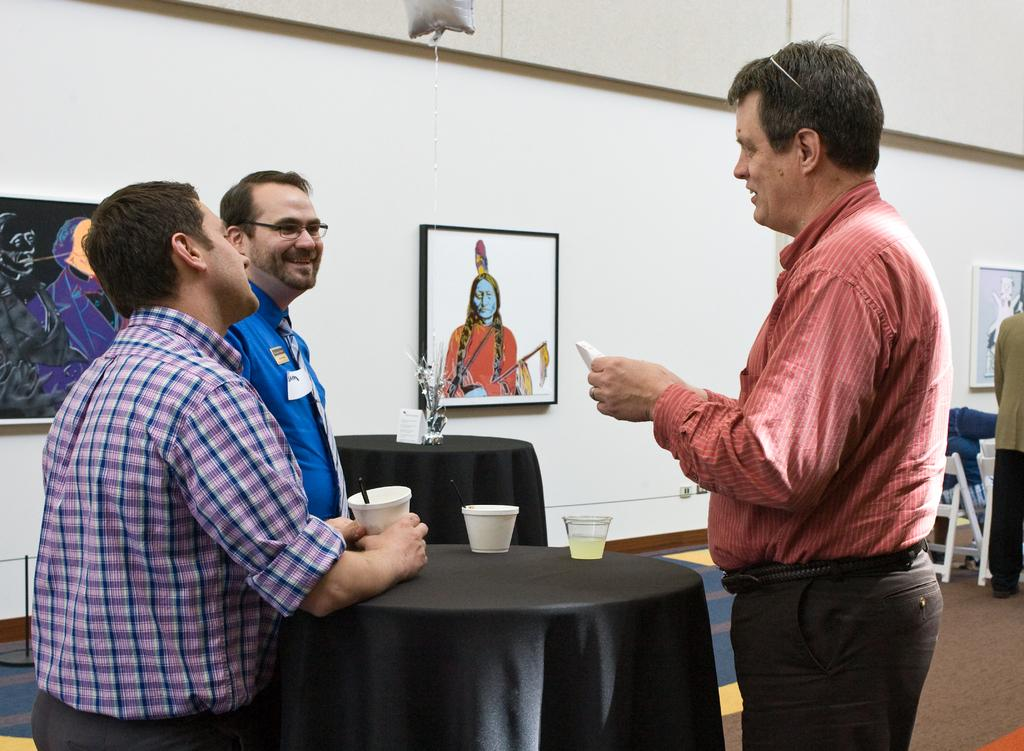How many people are in the image? There are three men in the image. What are the men doing in the image? The men are standing. What object can be seen on a table in the image? There is a cup on a table in the image. How many frames are hanging on the wall in the image? There are three frames on the wall in the image. What type of furniture is present in the image? There is a chair in the image. Can you tell me how many passengers are sitting on the squirrel in the image? There are no passengers or squirrels present in the image. Who is the father of the man in the image? The provided facts do not give any information about the men's family relationships, so it cannot be determined who their fathers are. 